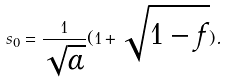<formula> <loc_0><loc_0><loc_500><loc_500>s _ { 0 } = \frac { 1 } { \sqrt { \alpha } } ( 1 + \sqrt { 1 - f } ) .</formula> 